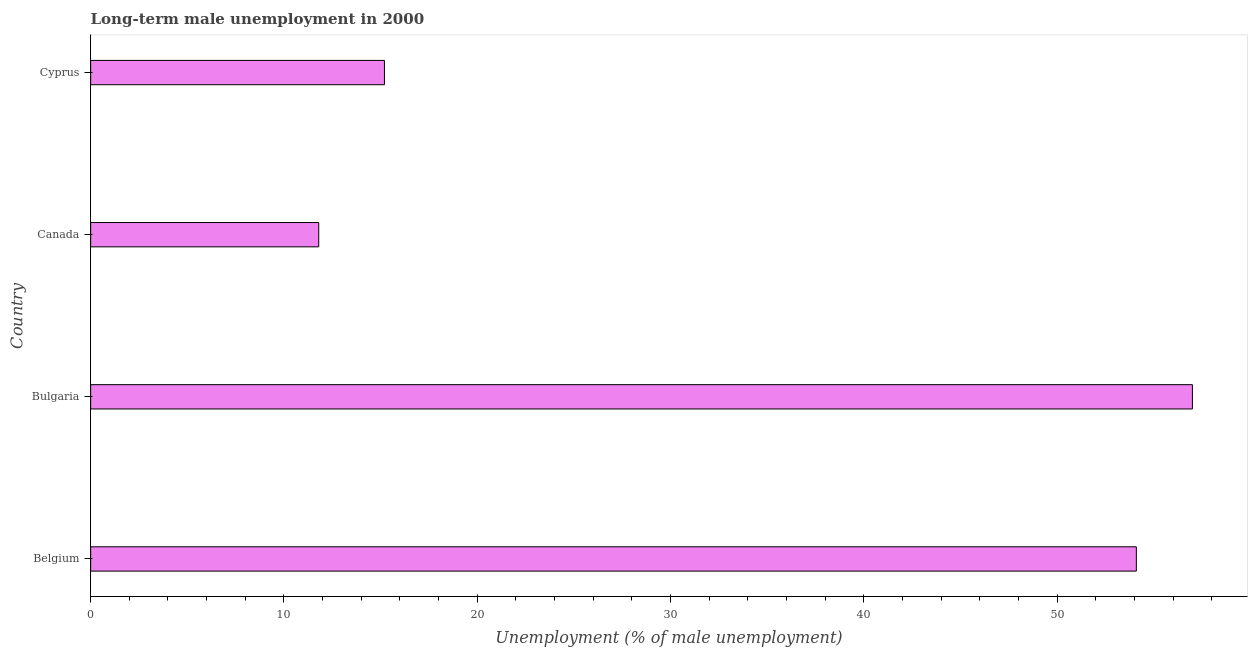Does the graph contain any zero values?
Provide a short and direct response. No. Does the graph contain grids?
Your answer should be compact. No. What is the title of the graph?
Give a very brief answer. Long-term male unemployment in 2000. What is the label or title of the X-axis?
Your answer should be compact. Unemployment (% of male unemployment). What is the label or title of the Y-axis?
Make the answer very short. Country. What is the long-term male unemployment in Bulgaria?
Ensure brevity in your answer.  57. Across all countries, what is the minimum long-term male unemployment?
Provide a succinct answer. 11.8. In which country was the long-term male unemployment maximum?
Provide a succinct answer. Bulgaria. In which country was the long-term male unemployment minimum?
Your response must be concise. Canada. What is the sum of the long-term male unemployment?
Offer a terse response. 138.1. What is the difference between the long-term male unemployment in Bulgaria and Canada?
Offer a very short reply. 45.2. What is the average long-term male unemployment per country?
Offer a very short reply. 34.52. What is the median long-term male unemployment?
Provide a succinct answer. 34.65. What is the ratio of the long-term male unemployment in Bulgaria to that in Canada?
Your answer should be very brief. 4.83. What is the difference between the highest and the lowest long-term male unemployment?
Provide a short and direct response. 45.2. In how many countries, is the long-term male unemployment greater than the average long-term male unemployment taken over all countries?
Provide a succinct answer. 2. What is the difference between two consecutive major ticks on the X-axis?
Provide a succinct answer. 10. What is the Unemployment (% of male unemployment) of Belgium?
Give a very brief answer. 54.1. What is the Unemployment (% of male unemployment) in Canada?
Provide a short and direct response. 11.8. What is the Unemployment (% of male unemployment) in Cyprus?
Give a very brief answer. 15.2. What is the difference between the Unemployment (% of male unemployment) in Belgium and Bulgaria?
Your answer should be compact. -2.9. What is the difference between the Unemployment (% of male unemployment) in Belgium and Canada?
Provide a short and direct response. 42.3. What is the difference between the Unemployment (% of male unemployment) in Belgium and Cyprus?
Keep it short and to the point. 38.9. What is the difference between the Unemployment (% of male unemployment) in Bulgaria and Canada?
Make the answer very short. 45.2. What is the difference between the Unemployment (% of male unemployment) in Bulgaria and Cyprus?
Keep it short and to the point. 41.8. What is the ratio of the Unemployment (% of male unemployment) in Belgium to that in Bulgaria?
Keep it short and to the point. 0.95. What is the ratio of the Unemployment (% of male unemployment) in Belgium to that in Canada?
Ensure brevity in your answer.  4.58. What is the ratio of the Unemployment (% of male unemployment) in Belgium to that in Cyprus?
Your response must be concise. 3.56. What is the ratio of the Unemployment (% of male unemployment) in Bulgaria to that in Canada?
Provide a succinct answer. 4.83. What is the ratio of the Unemployment (% of male unemployment) in Bulgaria to that in Cyprus?
Offer a terse response. 3.75. What is the ratio of the Unemployment (% of male unemployment) in Canada to that in Cyprus?
Provide a succinct answer. 0.78. 